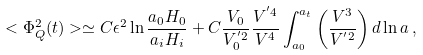<formula> <loc_0><loc_0><loc_500><loc_500>< \Phi _ { Q } ^ { 2 } ( t ) > \simeq C \epsilon ^ { 2 } \ln \frac { a _ { 0 } H _ { 0 } } { a _ { i } H _ { i } } + C \frac { V _ { 0 } } { V _ { 0 } ^ { ^ { \prime } 2 } } \frac { V ^ { ^ { \prime } 4 } } { V ^ { 4 } } \int _ { a _ { 0 } } ^ { a _ { t } } \left ( \frac { V ^ { 3 } } { V ^ { ^ { \prime } 2 } } \right ) d \ln a \, ,</formula> 